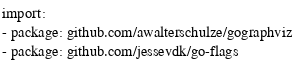Convert code to text. <code><loc_0><loc_0><loc_500><loc_500><_YAML_>import:
- package: github.com/awalterschulze/gographviz
- package: github.com/jessevdk/go-flags
</code> 